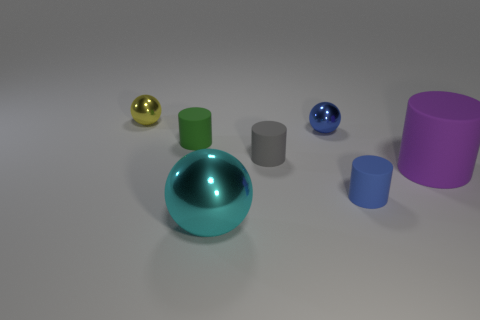Is there a source of light in the image, and if so, where is it coming from? There is no visible light source within the image, but the reflections and shadows on the objects suggest a light source coming from the upper left, outside the frame of the image. 